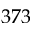Convert formula to latex. <formula><loc_0><loc_0><loc_500><loc_500>3 7 3</formula> 